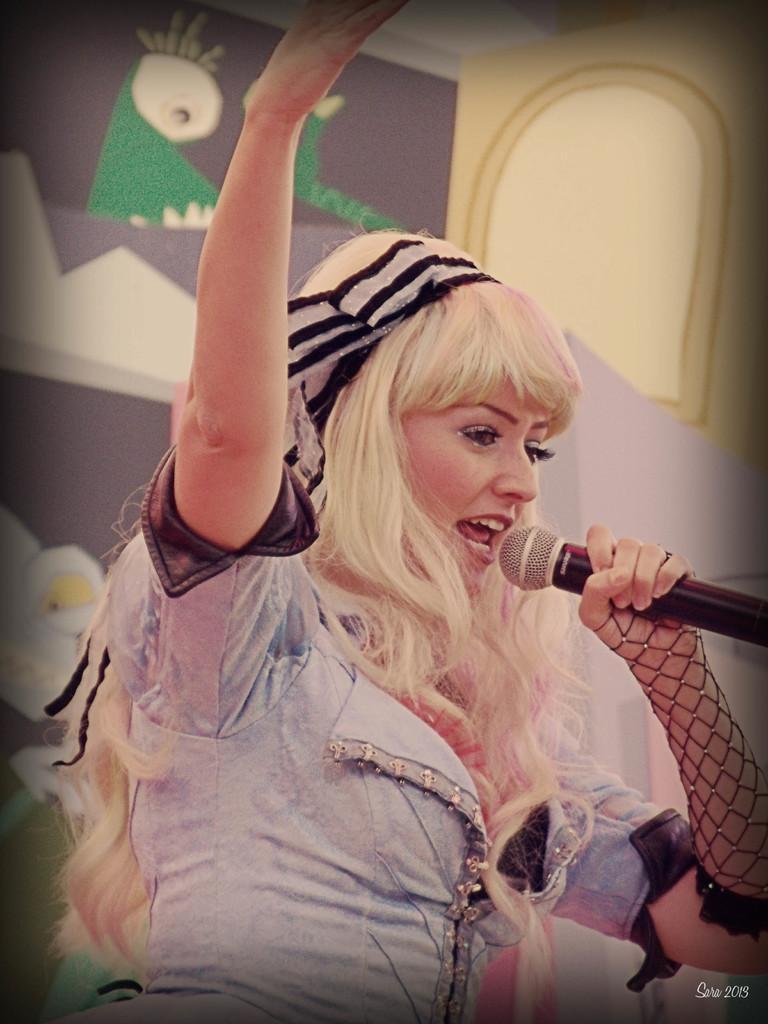In one or two sentences, can you explain what this image depicts? This picture shows a woman singing by holding a microphone in hand 